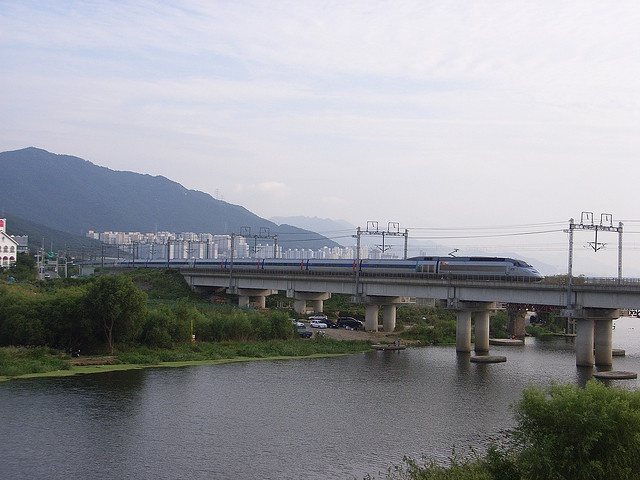Describe the objects in this image and their specific colors. I can see train in lavender, gray, black, and navy tones, car in lavender, black, gray, and darkgray tones, car in lavender, black, gray, and purple tones, car in lavender, gray, and black tones, and car in lavender, black, gray, and darkgray tones in this image. 